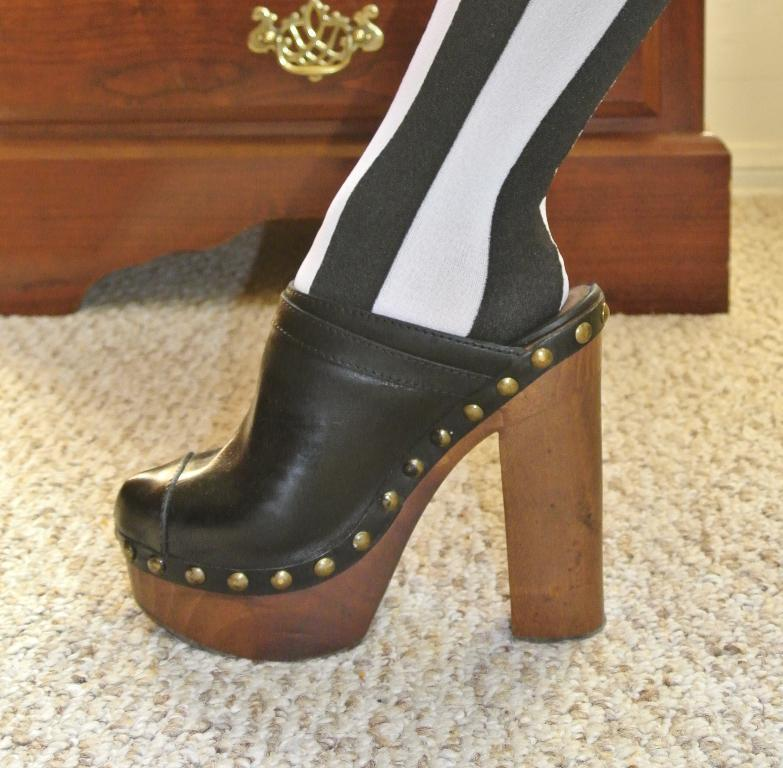What is: What is the focus of the image? The image is zoomed in on a leg of a person wearing heels. What can be seen in the background of the image? There is a wooden object in the background of the image. What is covering the ground in the image? The ground is covered with a floor mat. How much rice is being cooked by the giants in the image? There are no giants or rice present in the image. What trick is being performed by the person wearing heels in the image? The image does not show any tricks being performed; it simply shows a leg of a person wearing heels. 